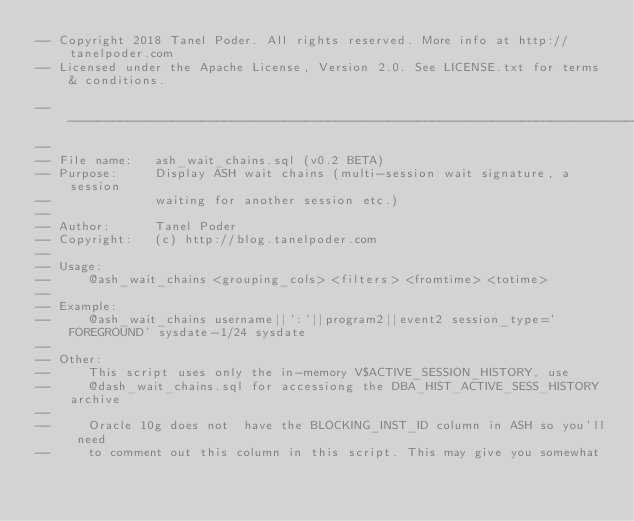<code> <loc_0><loc_0><loc_500><loc_500><_SQL_>-- Copyright 2018 Tanel Poder. All rights reserved. More info at http://tanelpoder.com
-- Licensed under the Apache License, Version 2.0. See LICENSE.txt for terms & conditions.

--------------------------------------------------------------------------------
--
-- File name:   ash_wait_chains.sql (v0.2 BETA)
-- Purpose:     Display ASH wait chains (multi-session wait signature, a session
--              waiting for another session etc.)
--              
-- Author:      Tanel Poder
-- Copyright:   (c) http://blog.tanelpoder.com
--              
-- Usage:       
--     @ash_wait_chains <grouping_cols> <filters> <fromtime> <totime>
--
-- Example:
--     @ash_wait_chains username||':'||program2||event2 session_type='FOREGROUND' sysdate-1/24 sysdate
--
-- Other:
--     This script uses only the in-memory V$ACTIVE_SESSION_HISTORY, use
--     @dash_wait_chains.sql for accessiong the DBA_HIST_ACTIVE_SESS_HISTORY archive
--
--     Oracle 10g does not  have the BLOCKING_INST_ID column in ASH so you'll need
--     to comment out this column in this script. This may give you somewhat</code> 